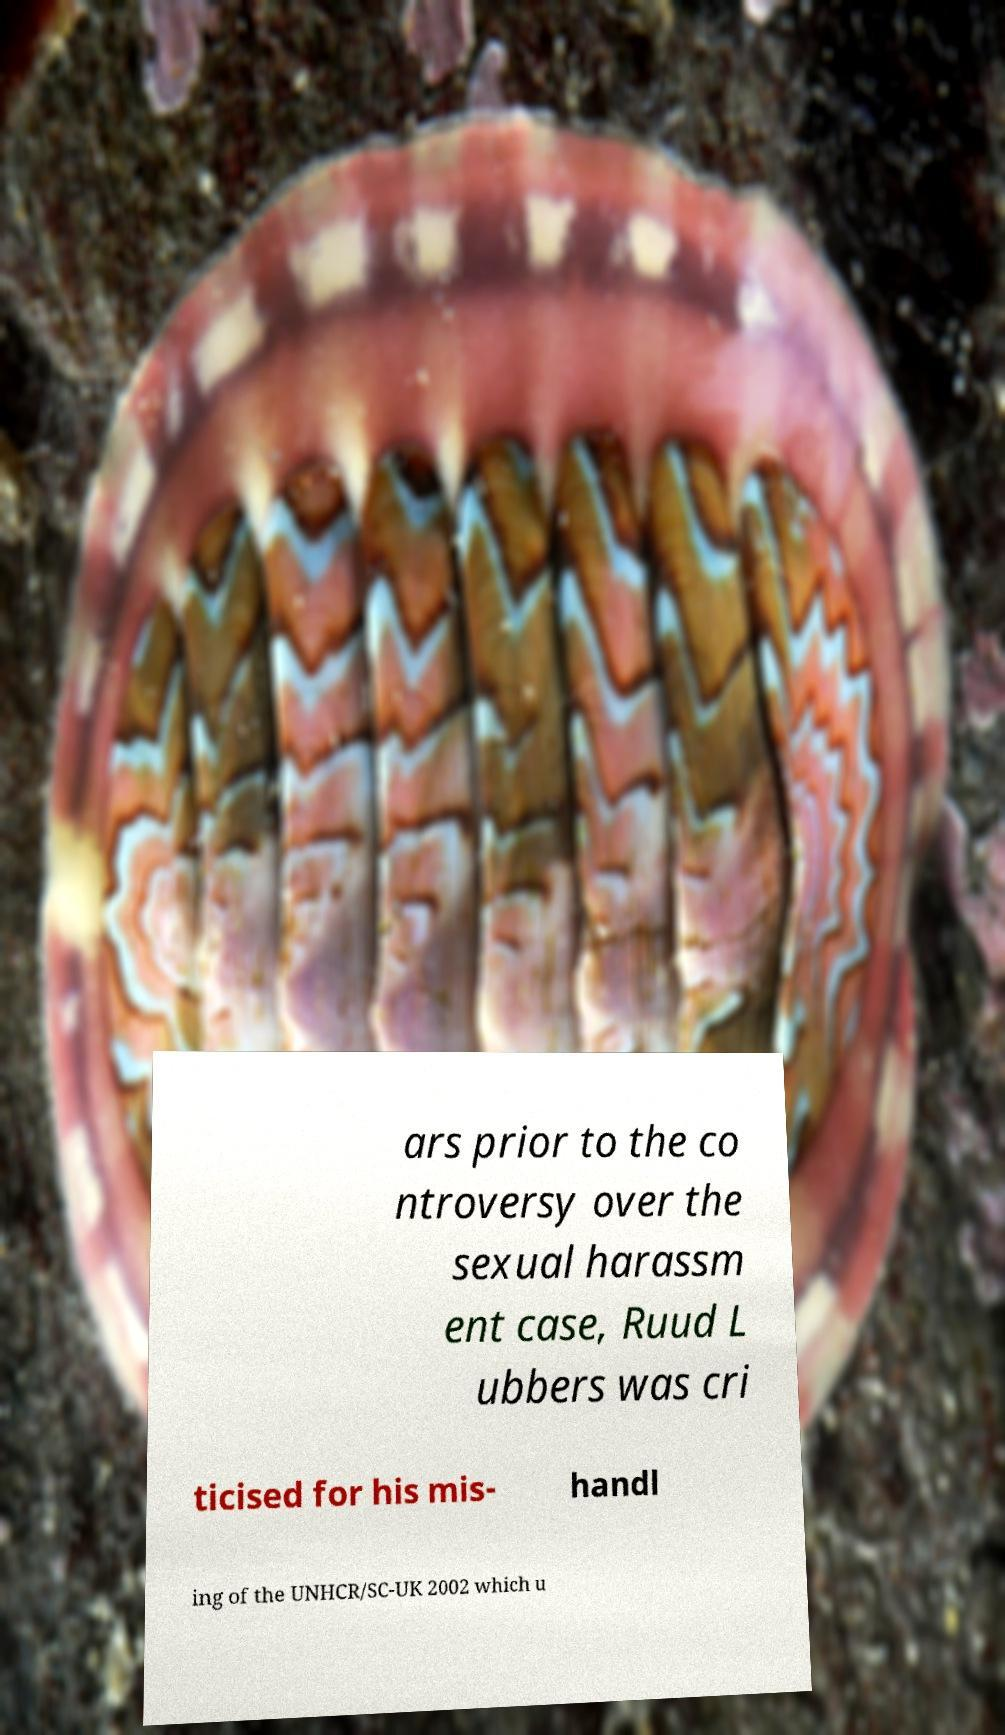For documentation purposes, I need the text within this image transcribed. Could you provide that? ars prior to the co ntroversy over the sexual harassm ent case, Ruud L ubbers was cri ticised for his mis- handl ing of the UNHCR/SC-UK 2002 which u 